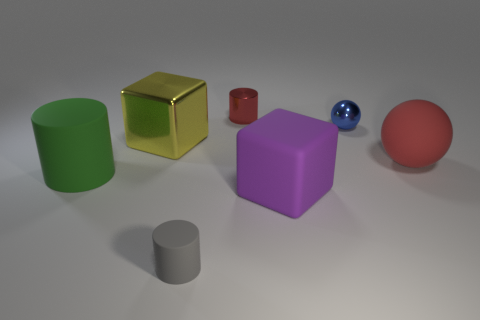Subtract all green cylinders. How many cylinders are left? 2 Add 1 red metal cylinders. How many objects exist? 8 Subtract 1 cubes. How many cubes are left? 1 Subtract all red cylinders. How many cylinders are left? 2 Subtract all large yellow matte objects. Subtract all green matte cylinders. How many objects are left? 6 Add 5 green cylinders. How many green cylinders are left? 6 Add 7 large green objects. How many large green objects exist? 8 Subtract 1 gray cylinders. How many objects are left? 6 Subtract all cubes. How many objects are left? 5 Subtract all red blocks. Subtract all brown cylinders. How many blocks are left? 2 